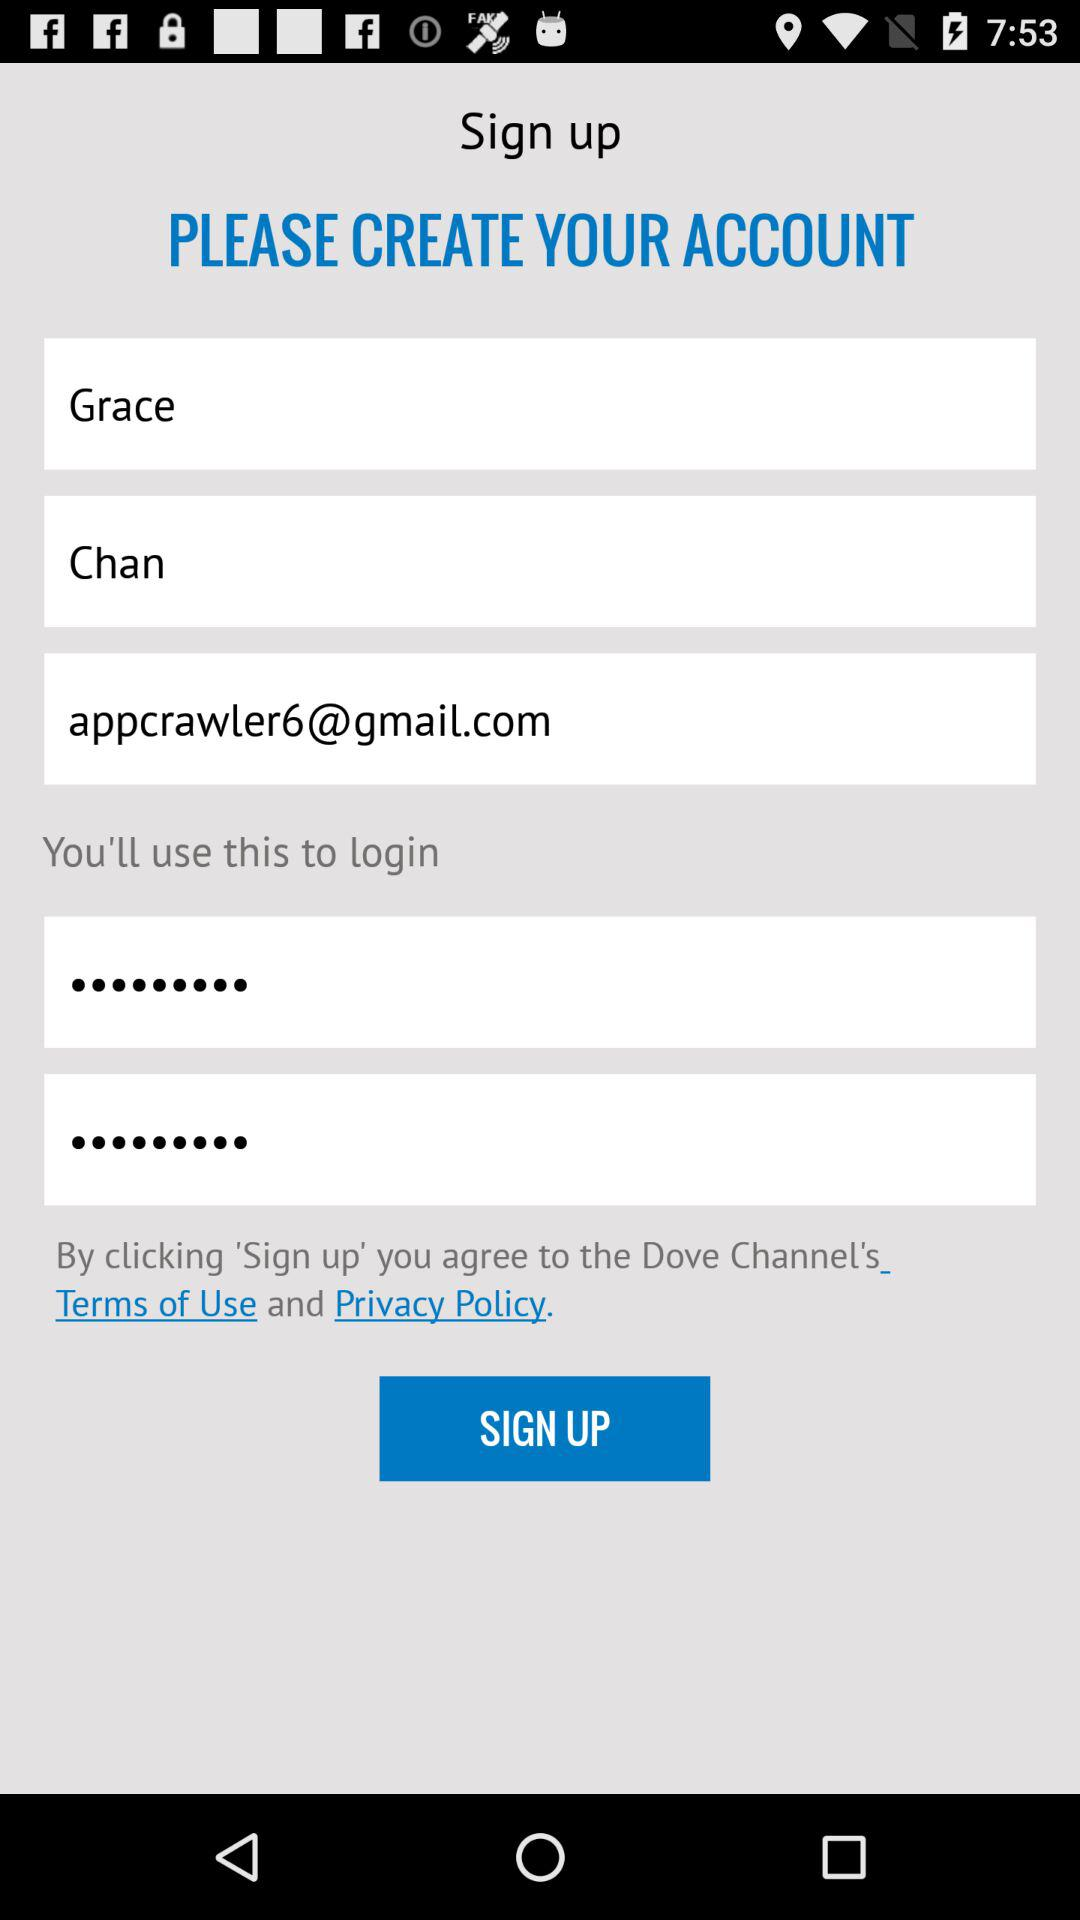What is the Gmail account? The Gmail account is appcrawler6@gmail.com. 